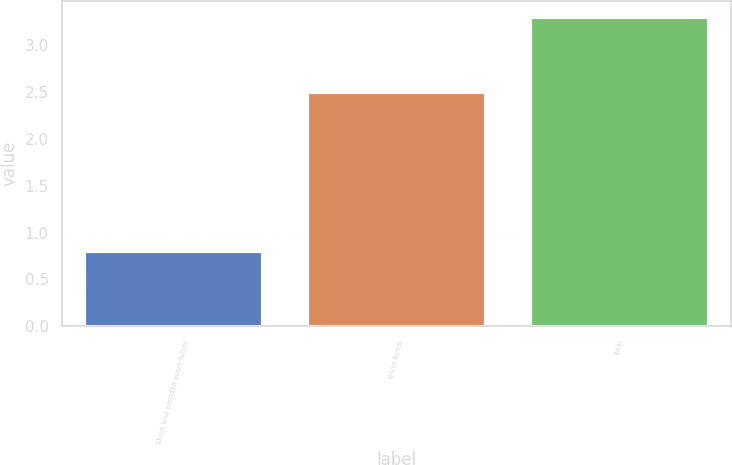Convert chart. <chart><loc_0><loc_0><loc_500><loc_500><bar_chart><fcel>Stock and blended asset funds<fcel>Bond funds<fcel>Total<nl><fcel>0.8<fcel>2.5<fcel>3.3<nl></chart> 